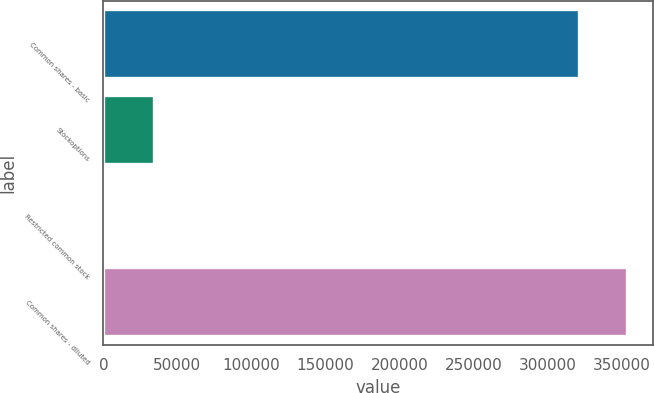Convert chart to OTSL. <chart><loc_0><loc_0><loc_500><loc_500><bar_chart><fcel>Common shares - basic<fcel>Stockoptions<fcel>Restricted common stock<fcel>Common shares - diluted<nl><fcel>320803<fcel>34218.2<fcel>1815<fcel>353206<nl></chart> 